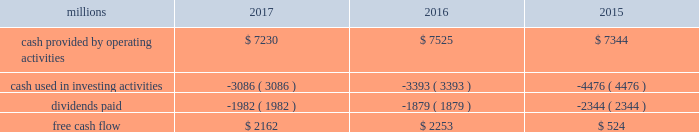Adjusted net income of $ 4.6 billion translated into adjusted earnings of $ 5.79 per diluted share , a best- ever performance .
F0b7 freight revenues 2013 our freight revenues increased 7% ( 7 % ) year-over-year to $ 19.8 billion driven by volume growth of 2% ( 2 % ) , higher fuel surcharge revenue , and core pricing gains .
Growth in frac sand , coal , and intermodal shipments more than offset declines in grain , crude oil , finished vehicles , and rock shipments .
F0b7 fuel prices 2013 our average price of diesel fuel in 2017 was $ 1.81 per gallon , an increase of 22% ( 22 % ) from 2016 , as both crude oil and conversion spreads between crude oil and diesel increased in 2017 .
The higher price resulted in increased operating expenses of $ 334 million ( excluding any impact from year- over-year volume growth ) .
Gross-ton miles increased 5% ( 5 % ) , which also drove higher fuel expense .
Our fuel consumption rate , computed as gallons of fuel consumed divided by gross ton-miles in thousands , improved 2% ( 2 % ) .
F0b7 free cash flow 2013 cash generated by operating activities totaled $ 7.2 billion , yielding free cash flow of $ 2.2 billion after reductions of $ 3.1 billion for cash used in investing activities and $ 2 billion in dividends , which included a 10% ( 10 % ) increase in our quarterly dividend per share from $ 0.605 to $ 0.665 declared and paid in the fourth quarter of 2017 .
Free cash flow is defined as cash provided by operating activities less cash used in investing activities and dividends paid .
Free cash flow is not considered a financial measure under gaap by sec regulation g and item 10 of sec regulation s-k and may not be defined and calculated by other companies in the same manner .
We believe free cash flow is important to management and investors in evaluating our financial performance and measures our ability to generate cash without additional external financings .
Free cash flow should be considered in addition to , rather than as a substitute for , cash provided by operating activities .
The table reconciles cash provided by operating activities ( gaap measure ) to free cash flow ( non-gaap measure ) : .
2018 outlook f0b7 safety 2013 operating a safe railroad benefits all our constituents : our employees , customers , shareholders and the communities we serve .
We will continue using a multi-faceted approach to safety , utilizing technology , risk assessment , training and employee engagement , quality control , and targeted capital investments .
We will continue using and expanding the deployment of total safety culture and courage to care throughout our operations , which allows us to identify and implement best practices for employee and operational safety .
We will continue our efforts to increase detection of rail defects ; improve or close crossings ; and educate the public and law enforcement agencies about crossing safety through a combination of our own programs ( including risk assessment strategies ) , industry programs and local community activities across our network .
F0b7 network operations 2013 in 2018 , we will continue to align resources with customer demand , maintain an efficient network , and ensure surge capability of our assets .
F0b7 fuel prices 2013 fuel price projections for crude oil and natural gas continue to fluctuate in the current environment .
We again could see volatile fuel prices during the year , as they are sensitive to global and u.s .
Domestic demand , refining capacity , geopolitical events , weather conditions and other factors .
As prices fluctuate , there will be a timing impact on earnings , as our fuel surcharge programs trail increases or decreases in fuel price by approximately two months .
Lower fuel prices could have a positive impact on the economy by increasing consumer discretionary spending that potentially could increase demand for various consumer products that we transport .
Alternatively , lower fuel prices could likely have a negative impact on other commodities such as coal and domestic drilling-related shipments. .
What was the percentage change in free cash flow from 2015 to 2016? 
Computations: ((2253 - 524) / 524)
Answer: 3.29962. 